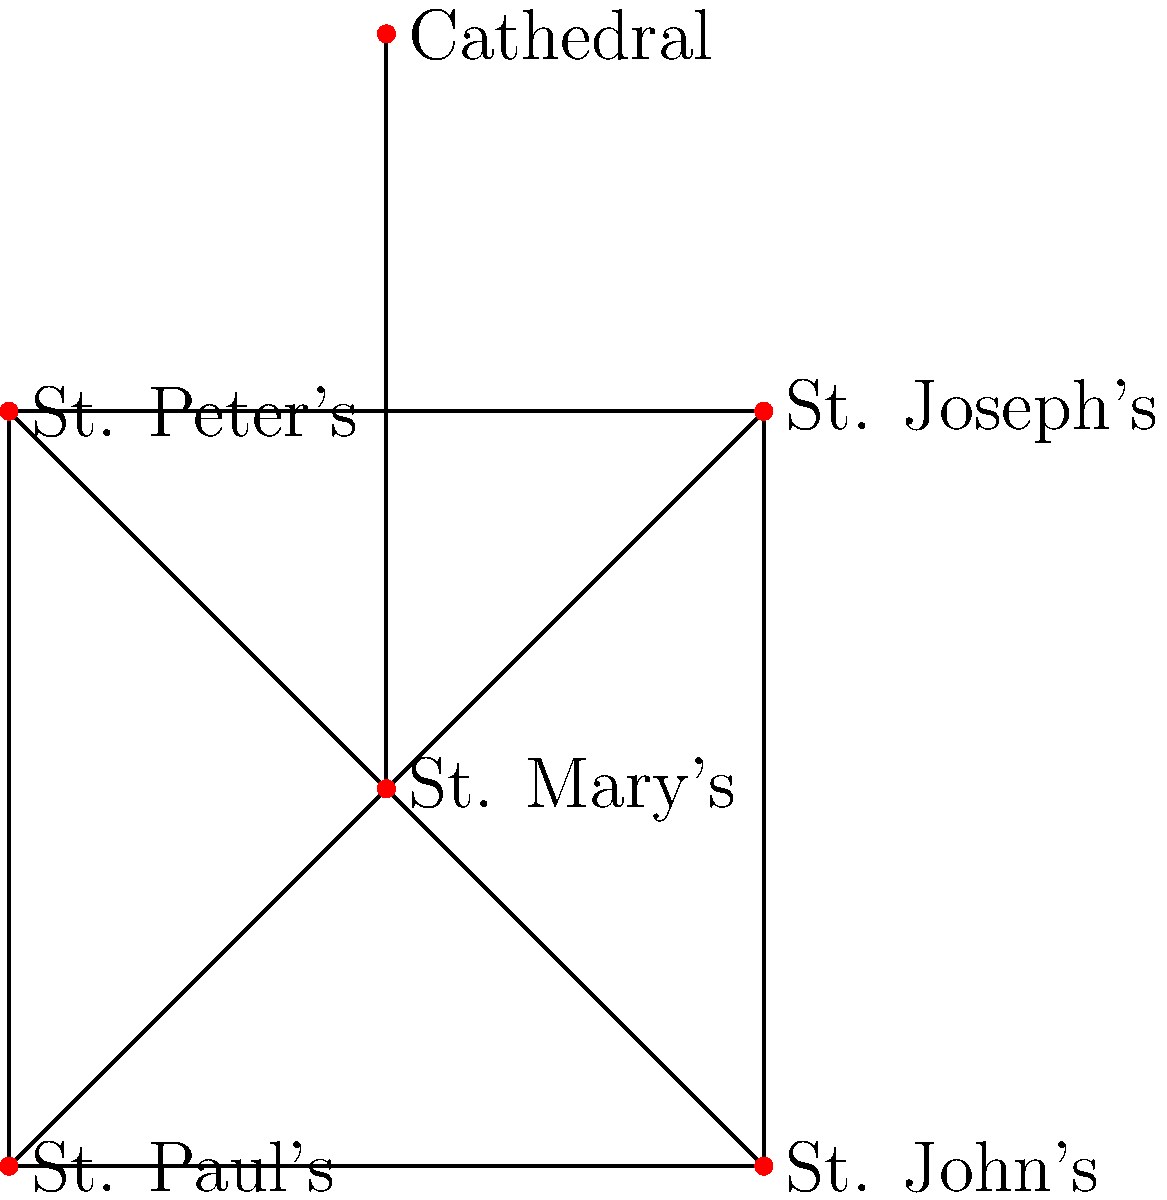In this network diagram representing the connectivity between Catholic parishes in a diocese, which parish acts as the central hub, connecting to all other parishes, and what does this structure symbolize in terms of traditional Catholic hierarchy? To answer this question, let's analyze the network diagram step-by-step:

1. Observe the structure of the network:
   - There are six nodes, each representing a parish or the cathedral.
   - One node is centrally located and connected to all other nodes.

2. Identify the central node:
   - The node labeled "St. Mary's" is connected to all other nodes in the network.
   - This makes St. Mary's the central hub of the network.

3. Understand the significance of this structure:
   - In traditional Catholic hierarchy, the cathedral church is often the central point of a diocese.
   - However, in this case, St. Mary's seems to play this central role, not the labeled "Cathedral".

4. Interpret the symbolism:
   - The central position of St. Mary's could represent:
     a) Its historical importance in the diocese
     b) Its role as a administrative or spiritual center
     c) Its function as a coordinating parish for diocesan activities

5. Relate to Catholic tradition:
   - This structure reflects the interconnectedness of parishes within a diocese.
   - It also symbolizes the unity of the Church, with one central point connecting all others.

6. Consider the traditional hierarchy:
   - While the Bishop's seat is typically at the cathedral, this network shows a different structure.
   - This could represent a more distributed form of pastoral care and administration within the diocese.

Therefore, St. Mary's acts as the central hub in this network, symbolizing a focal point of unity and coordination within the diocese, while also representing a slight departure from the most traditional hierarchical structure centered on the cathedral.
Answer: St. Mary's; central point of unity and pastoral coordination 